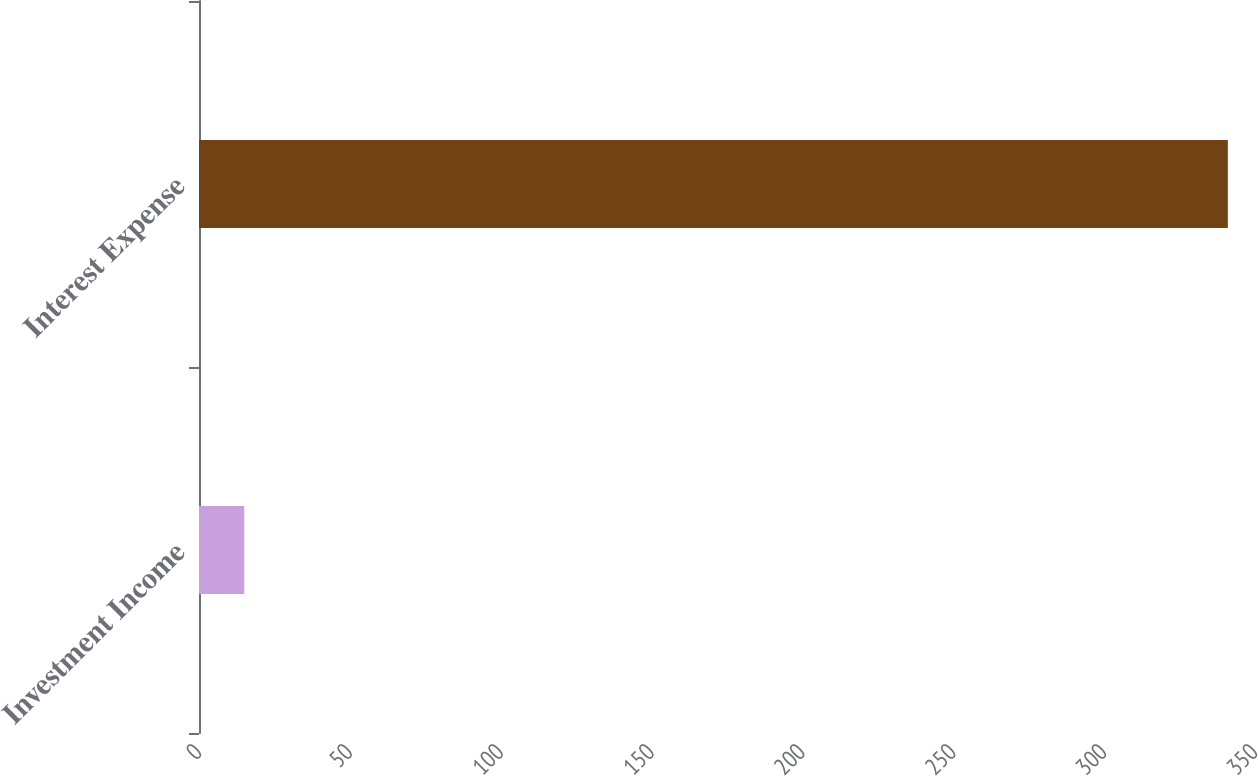Convert chart. <chart><loc_0><loc_0><loc_500><loc_500><bar_chart><fcel>Investment Income<fcel>Interest Expense<nl><fcel>15<fcel>341<nl></chart> 